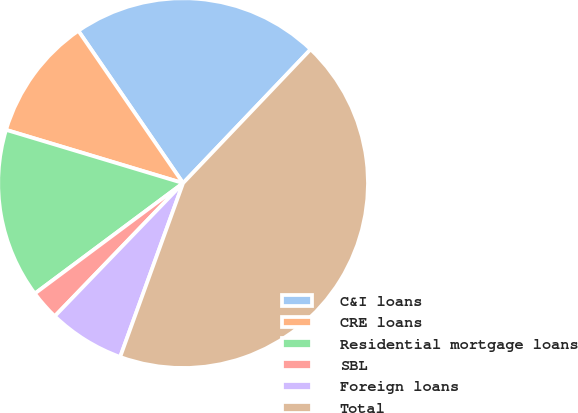<chart> <loc_0><loc_0><loc_500><loc_500><pie_chart><fcel>C&I loans<fcel>CRE loans<fcel>Residential mortgage loans<fcel>SBL<fcel>Foreign loans<fcel>Total<nl><fcel>21.7%<fcel>10.76%<fcel>14.84%<fcel>2.6%<fcel>6.68%<fcel>43.4%<nl></chart> 